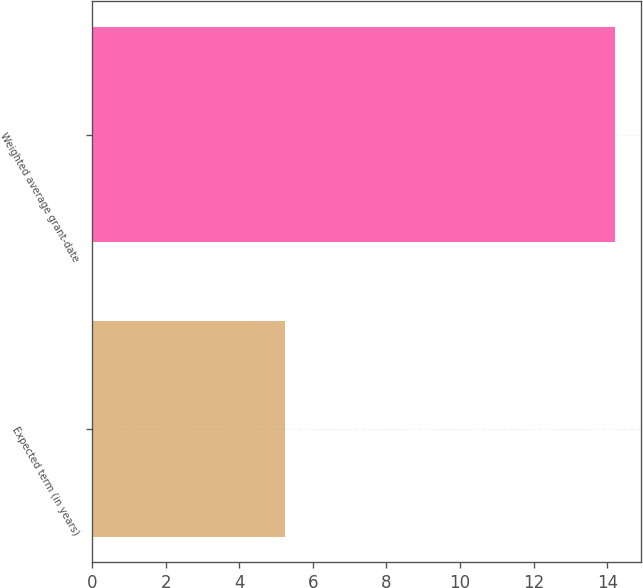Convert chart. <chart><loc_0><loc_0><loc_500><loc_500><bar_chart><fcel>Expected term (in years)<fcel>Weighted average grant-date<nl><fcel>5.24<fcel>14.2<nl></chart> 